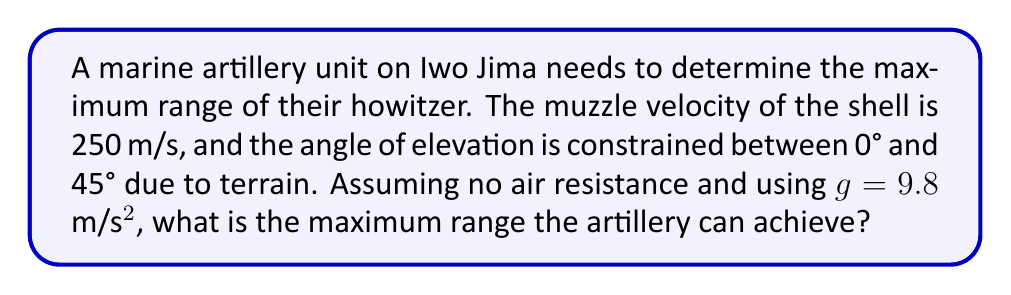Give your solution to this math problem. 1) The range of a projectile is given by the formula:
   $$R = \frac{v^2 \sin(2\theta)}{g}$$
   where $R$ is the range, $v$ is the muzzle velocity, $\theta$ is the angle of elevation, and $g$ is the acceleration due to gravity.

2) To find the maximum range, we need to maximize $\sin(2\theta)$. This occurs when $2\theta = 90°$ or $\theta = 45°$.

3) Fortunately, 45° is within our constrained range of 0° to 45°.

4) Substituting the values into the equation:
   $$R_{max} = \frac{(250 \text{ m/s})^2 \sin(2 \cdot 45°)}{9.8 \text{ m/s}^2}$$

5) Simplify:
   $$R_{max} = \frac{62500 \text{ m}^2 \cdot 1}{9.8 \text{ m/s}^2}$$

6) Calculate:
   $$R_{max} = 6377.55 \text{ m}$$

7) Round to a reasonable precision for artillery:
   $$R_{max} \approx 6378 \text{ m}$$
Answer: 6378 m 